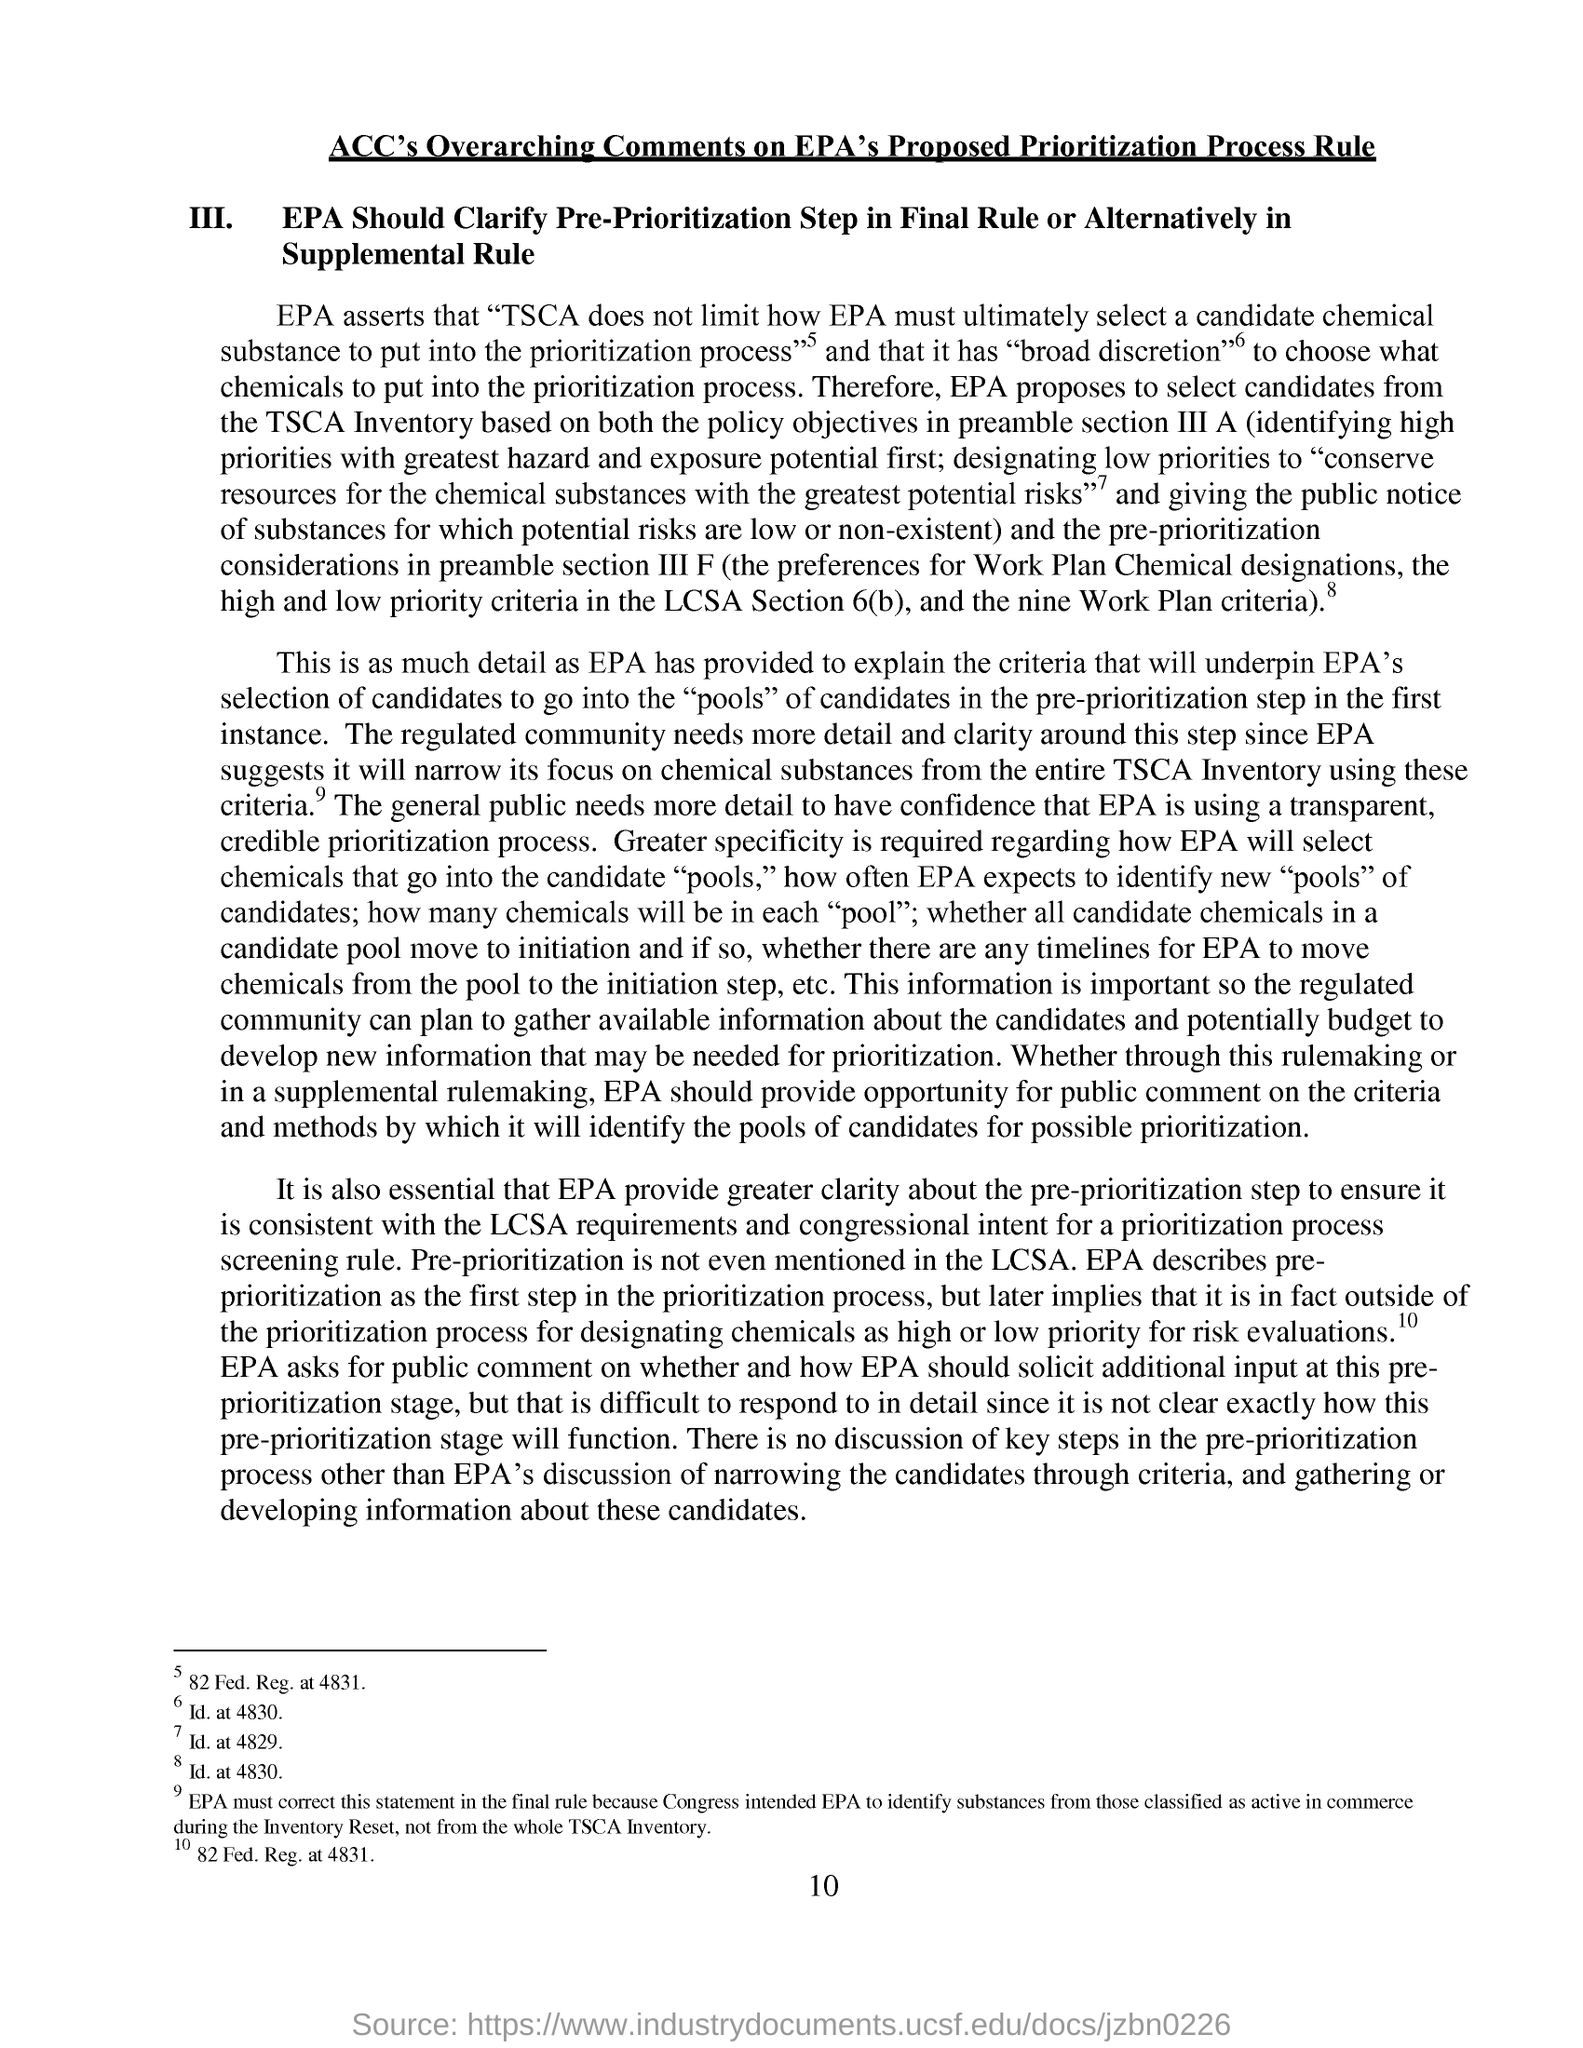What is the page no mentioned in this document?
Make the answer very short. 10. 